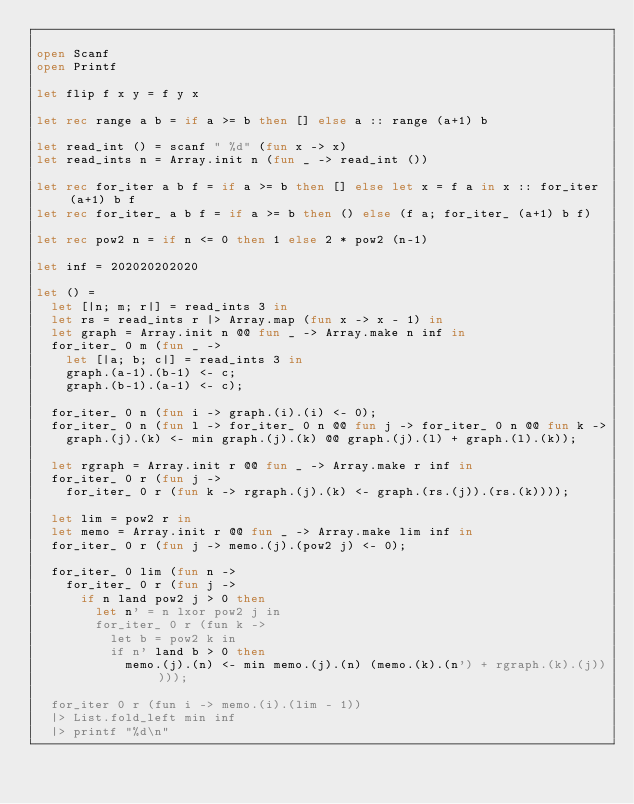Convert code to text. <code><loc_0><loc_0><loc_500><loc_500><_OCaml_>
open Scanf
open Printf

let flip f x y = f y x

let rec range a b = if a >= b then [] else a :: range (a+1) b

let read_int () = scanf " %d" (fun x -> x)
let read_ints n = Array.init n (fun _ -> read_int ())

let rec for_iter a b f = if a >= b then [] else let x = f a in x :: for_iter (a+1) b f
let rec for_iter_ a b f = if a >= b then () else (f a; for_iter_ (a+1) b f)

let rec pow2 n = if n <= 0 then 1 else 2 * pow2 (n-1)

let inf = 202020202020

let () =
  let [|n; m; r|] = read_ints 3 in
  let rs = read_ints r |> Array.map (fun x -> x - 1) in
  let graph = Array.init n @@ fun _ -> Array.make n inf in
  for_iter_ 0 m (fun _ ->
    let [|a; b; c|] = read_ints 3 in
    graph.(a-1).(b-1) <- c;
    graph.(b-1).(a-1) <- c);

  for_iter_ 0 n (fun i -> graph.(i).(i) <- 0);
  for_iter_ 0 n (fun l -> for_iter_ 0 n @@ fun j -> for_iter_ 0 n @@ fun k ->
    graph.(j).(k) <- min graph.(j).(k) @@ graph.(j).(l) + graph.(l).(k));

  let rgraph = Array.init r @@ fun _ -> Array.make r inf in
  for_iter_ 0 r (fun j ->
    for_iter_ 0 r (fun k -> rgraph.(j).(k) <- graph.(rs.(j)).(rs.(k))));

  let lim = pow2 r in
  let memo = Array.init r @@ fun _ -> Array.make lim inf in
  for_iter_ 0 r (fun j -> memo.(j).(pow2 j) <- 0);

  for_iter_ 0 lim (fun n ->
    for_iter_ 0 r (fun j ->
      if n land pow2 j > 0 then
        let n' = n lxor pow2 j in
        for_iter_ 0 r (fun k ->
          let b = pow2 k in
          if n' land b > 0 then
            memo.(j).(n) <- min memo.(j).(n) (memo.(k).(n') + rgraph.(k).(j)))));

  for_iter 0 r (fun i -> memo.(i).(lim - 1))
  |> List.fold_left min inf
  |> printf "%d\n"
</code> 